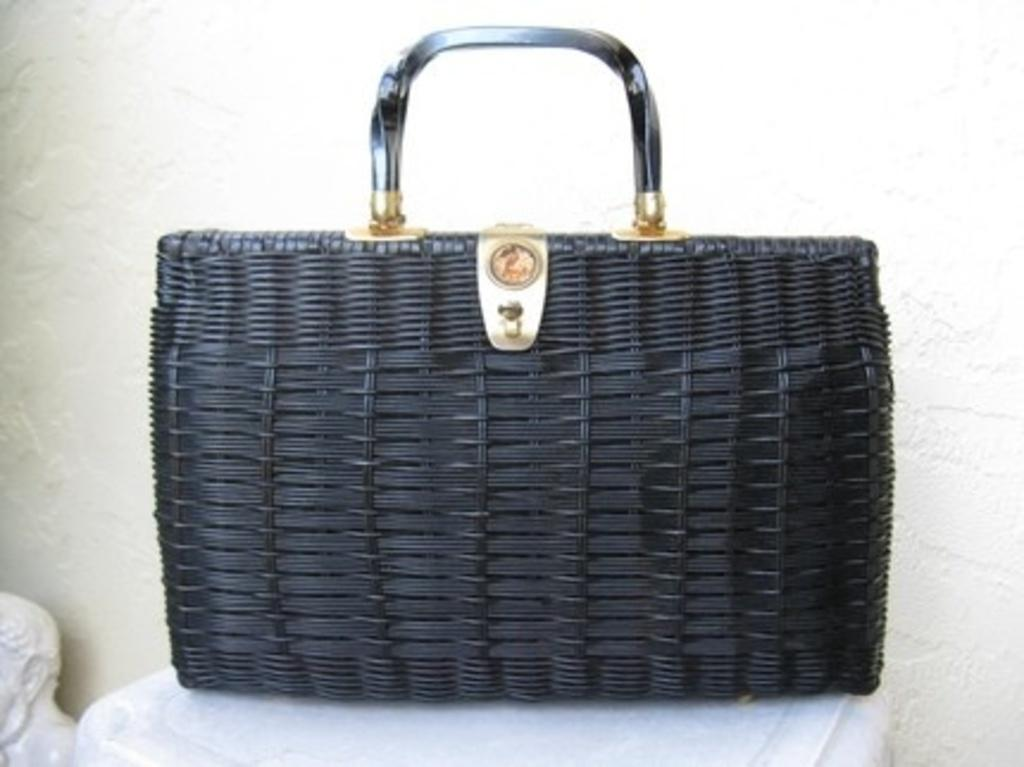What type of handbag is visible in the image? There is a black handbag in the image. What is the logo on the handbag? The handbag has a golden logo. How can the handbag be carried? The handbag has a handle for carrying. Where is the handbag placed in the image? The handbag is placed on a white table. What can be seen in the background of the image? There is a white wall in the background of the image. What type of pest can be seen crawling on the handbag in the image? There are no pests visible on the handbag in the image. What type of silk material is used to make the handbag in the image? The type of material used to make the handbag is not mentioned in the image. 